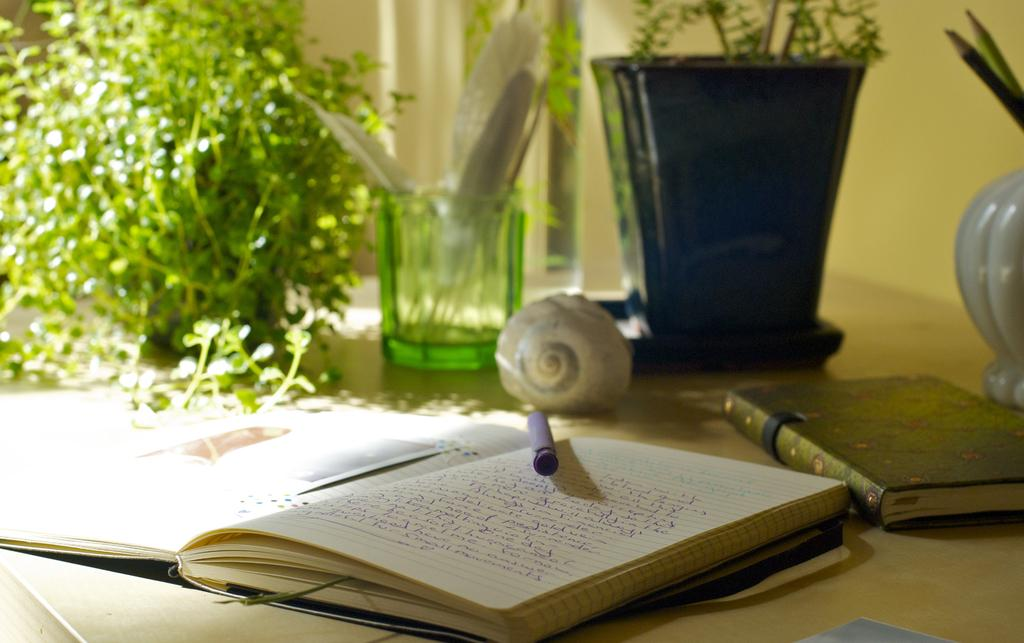What writing instrument is visible in the image? There is a pen in the image. What items are related to reading or learning in the image? There are books in the image. What type of decorative object can be seen in the image? There is a flower vase in the image. What type of container is visible in the image? There is a glass in the image. What type of living organism is present in the image? There is a plant in the image. What type of furniture is present in the image? There is a shelf in the image. What type of pain can be seen on the plant's face in the image? There is no face or expression of pain on the plant in the image, as plants do not have faces or the ability to feel pain. How many pigs are visible in the image? There are no pigs present in the image. 